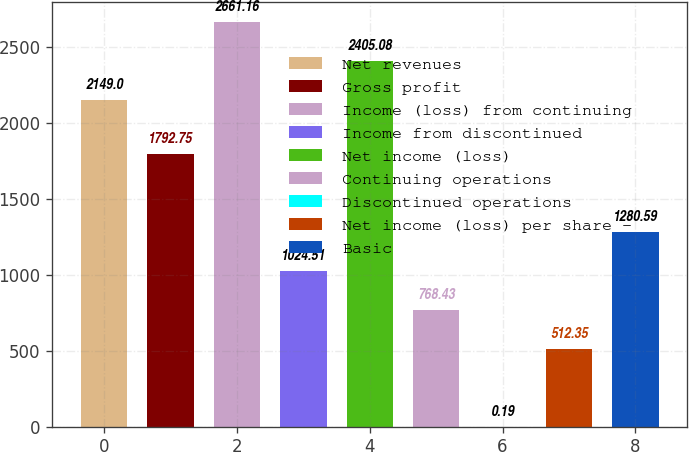<chart> <loc_0><loc_0><loc_500><loc_500><bar_chart><fcel>Net revenues<fcel>Gross profit<fcel>Income (loss) from continuing<fcel>Income from discontinued<fcel>Net income (loss)<fcel>Continuing operations<fcel>Discontinued operations<fcel>Net income (loss) per share -<fcel>Basic<nl><fcel>2149<fcel>1792.75<fcel>2661.16<fcel>1024.51<fcel>2405.08<fcel>768.43<fcel>0.19<fcel>512.35<fcel>1280.59<nl></chart> 